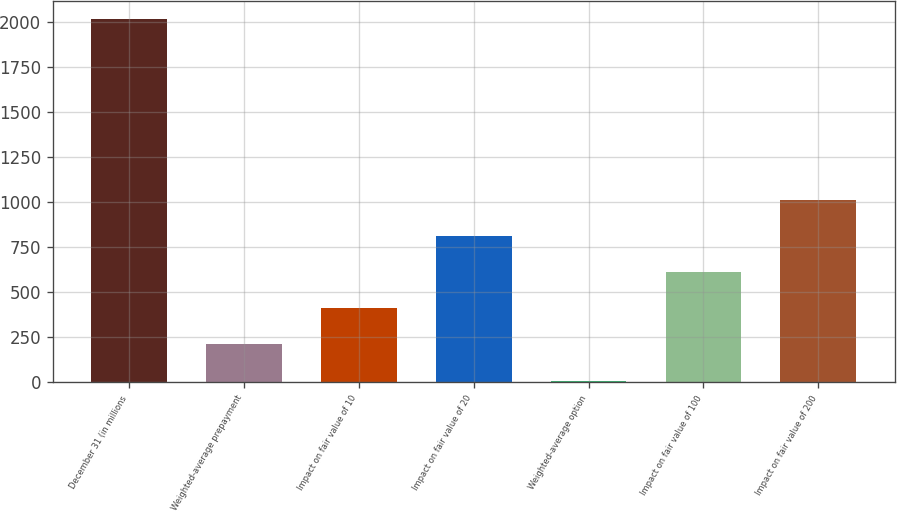<chart> <loc_0><loc_0><loc_500><loc_500><bar_chart><fcel>December 31 (in millions<fcel>Weighted-average prepayment<fcel>Impact on fair value of 10<fcel>Impact on fair value of 20<fcel>Weighted-average option<fcel>Impact on fair value of 100<fcel>Impact on fair value of 200<nl><fcel>2016<fcel>209.3<fcel>410.05<fcel>811.54<fcel>8.55<fcel>610.8<fcel>1012.28<nl></chart> 